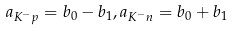Convert formula to latex. <formula><loc_0><loc_0><loc_500><loc_500>a _ { K ^ { - } p } = b _ { 0 } - b _ { 1 } , a _ { K ^ { - } n } = b _ { 0 } + b _ { 1 }</formula> 